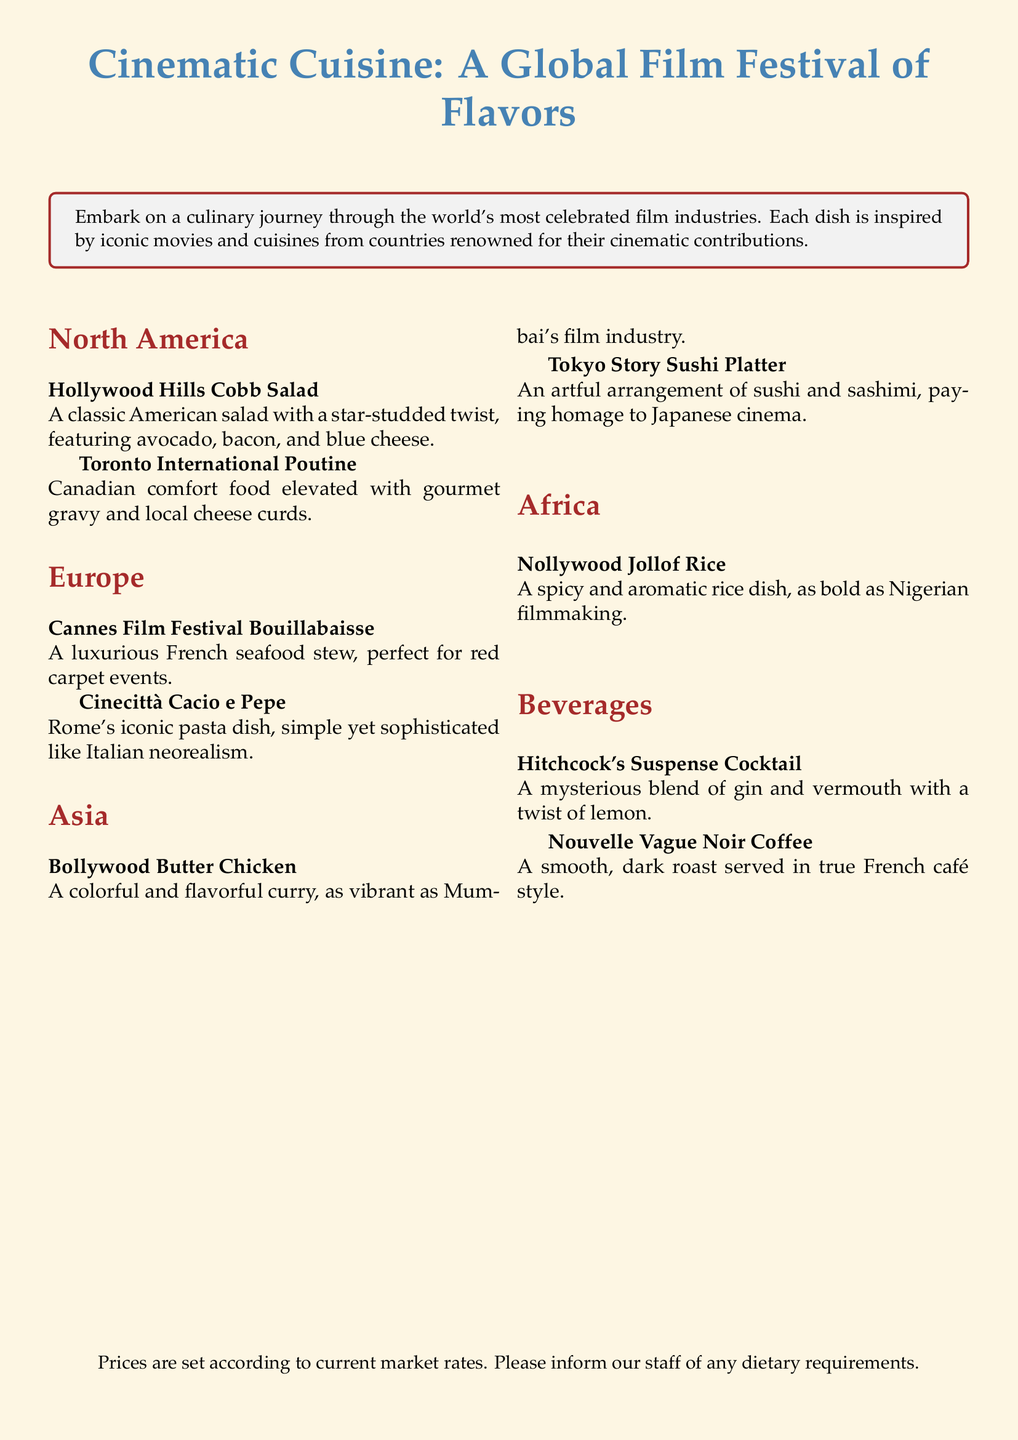what is the name of the salad dish in North America? The document lists the Hollywood Hills Cobb Salad as the salad dish under North America.
Answer: Hollywood Hills Cobb Salad which dish represents Japanese cinema in Asia? The Tokyo Story Sushi Platter is the dish associated with Japanese cinema in Asia according to the document.
Answer: Tokyo Story Sushi Platter how many dishes are listed under the Europe section? There are two dishes, Cannes Film Festival Bouillabaisse and Cinecittà Cacio e Pepe, under the Europe section.
Answer: 2 what type of coffee is served in the Beverages section? The beverages section mentions Nouvelle Vague Noir Coffee as the coffee option.
Answer: Nouvelle Vague Noir Coffee which dish is inspired by Nigerian filmmaking? The Nollywood Jollof Rice is inspired by Nigerian filmmaking as stated in the document.
Answer: Nollywood Jollof Rice what is the unique feature of the Hitchcock's Suspense Cocktail? The cocktail is described as having a mysterious blend of gin and vermouth with a twist of lemon.
Answer: Mysterious blend name one ingredient in the Toronto International Poutine. The Toronto International Poutine includes gourmet gravy as one of its ingredients.
Answer: Gourmet gravy 